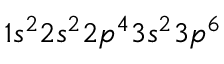<formula> <loc_0><loc_0><loc_500><loc_500>1 s ^ { 2 } 2 s ^ { 2 } 2 p ^ { 4 } 3 s ^ { 2 } 3 p ^ { 6 }</formula> 